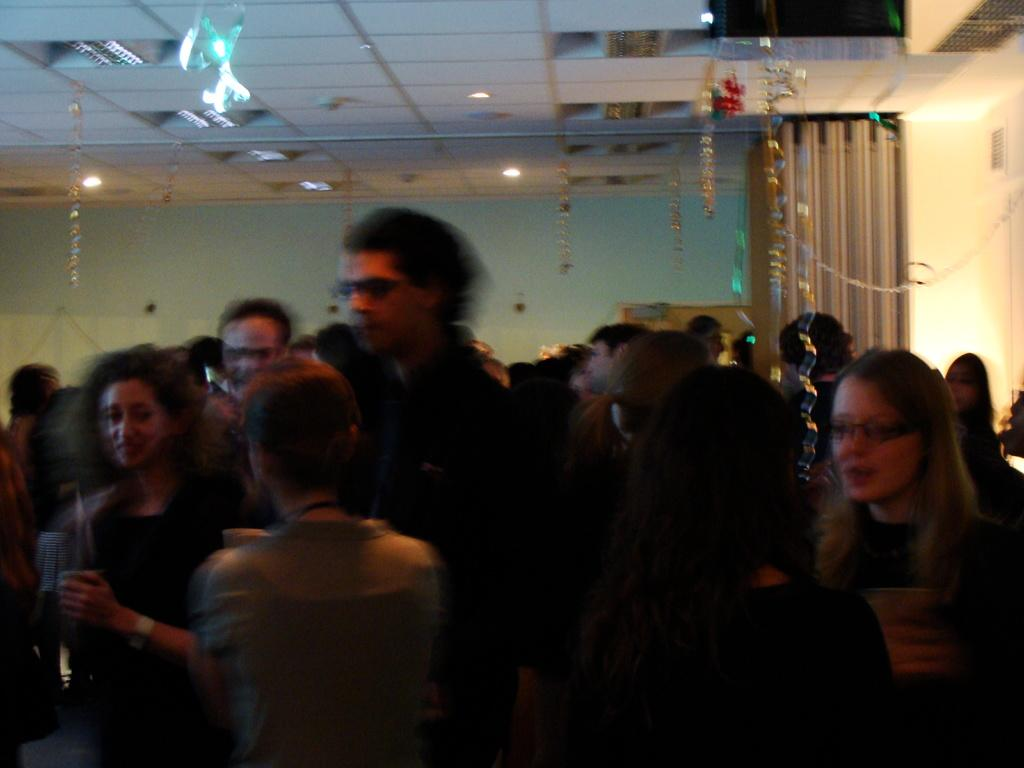Who or what is present in the image? There are people in the image. What can be seen at the top of the image? There are decorative items and lights visible at the top of the image. What is the ceiling like in the image? There is a ceiling visible at the top of the image. What is in the background of the image? There is a wall in the background of the image. What color is the ink used by the man in the image? There is no man present in the image, and therefore no ink usage can be observed. What thought process can be seen in the image? There is no indication of a thought process in the image; it only shows people, decorative items, lights, ceiling, and a wall. 